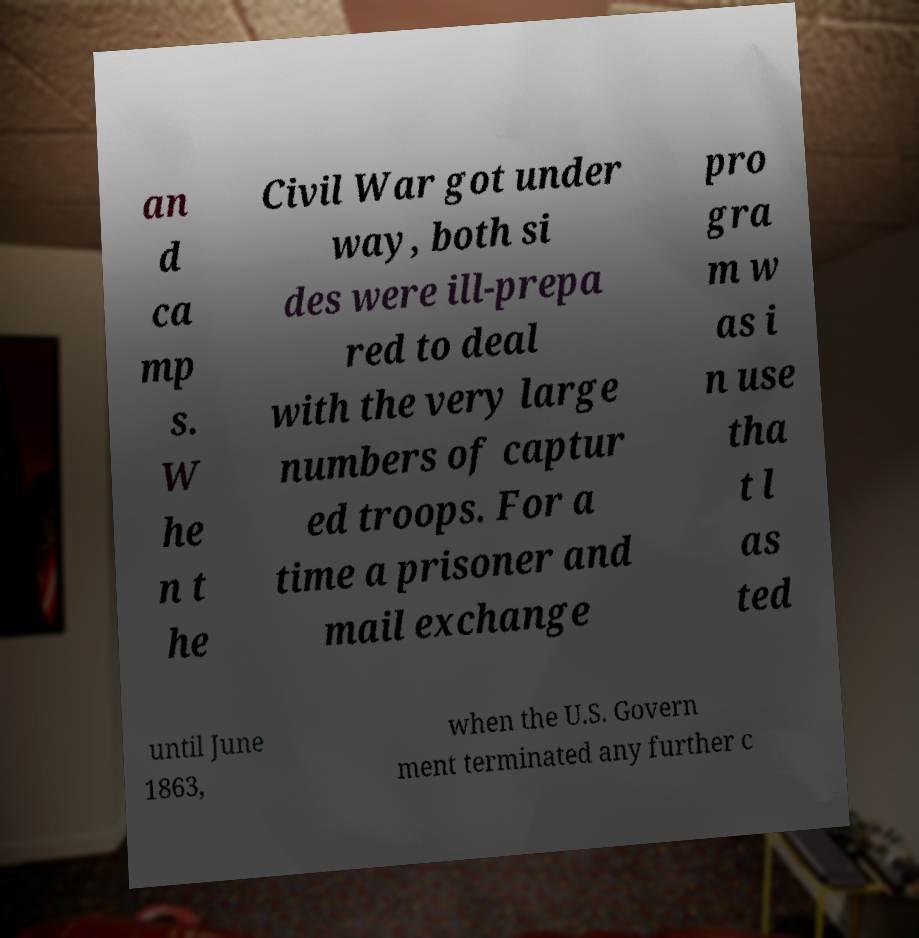Please read and relay the text visible in this image. What does it say? an d ca mp s. W he n t he Civil War got under way, both si des were ill-prepa red to deal with the very large numbers of captur ed troops. For a time a prisoner and mail exchange pro gra m w as i n use tha t l as ted until June 1863, when the U.S. Govern ment terminated any further c 